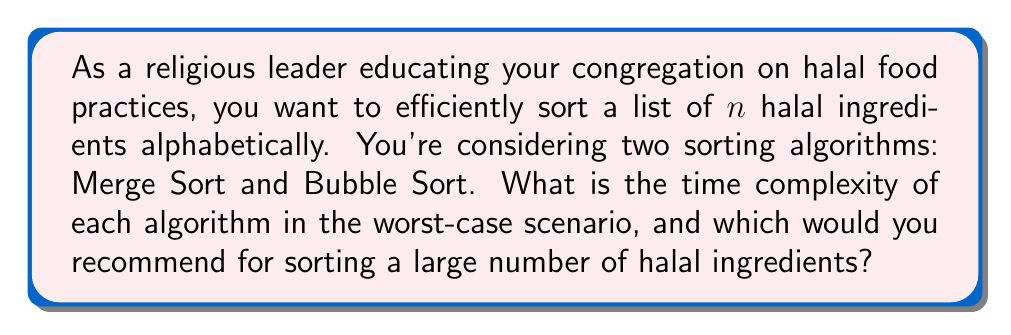Show me your answer to this math problem. To analyze the time complexity of these sorting algorithms, we need to consider their worst-case scenarios:

1. Merge Sort:
Merge Sort uses a divide-and-conquer approach. It recursively divides the list into halves until each sublist contains one element, then merges these sublists back together in sorted order.

The time complexity of Merge Sort can be expressed as:
$$T(n) = 2T(n/2) + O(n)$$

Where $T(n)$ is the time complexity for a list of size $n$, $2T(n/2)$ represents the two recursive calls on halves of the list, and $O(n)$ is the time for merging.

Solving this recurrence relation using the Master Theorem, we get:
$$T(n) = O(n \log n)$$

2. Bubble Sort:
Bubble Sort repeatedly steps through the list, compares adjacent elements, and swaps them if they're in the wrong order.

In the worst-case scenario (when the list is in reverse order), Bubble Sort makes:
- $(n-1)$ comparisons in the first pass
- $(n-2)$ comparisons in the second pass
- ...
- $1$ comparison in the last pass

The total number of comparisons is:
$$\sum_{i=1}^{n-1} i = \frac{n(n-1)}{2}$$

This sum is proportional to $n^2$, so the time complexity of Bubble Sort is:
$$O(n^2)$$

Comparing the two:
- Merge Sort: $O(n \log n)$
- Bubble Sort: $O(n^2)$

For large values of $n$, $n \log n$ grows much slower than $n^2$. Therefore, Merge Sort is significantly more efficient for large lists.

As a religious leader dealing with potentially large lists of halal ingredients, Merge Sort would be the recommended choice due to its superior efficiency for large datasets.
Answer: Merge Sort: $O(n \log n)$
Bubble Sort: $O(n^2)$
Recommendation: Merge Sort 